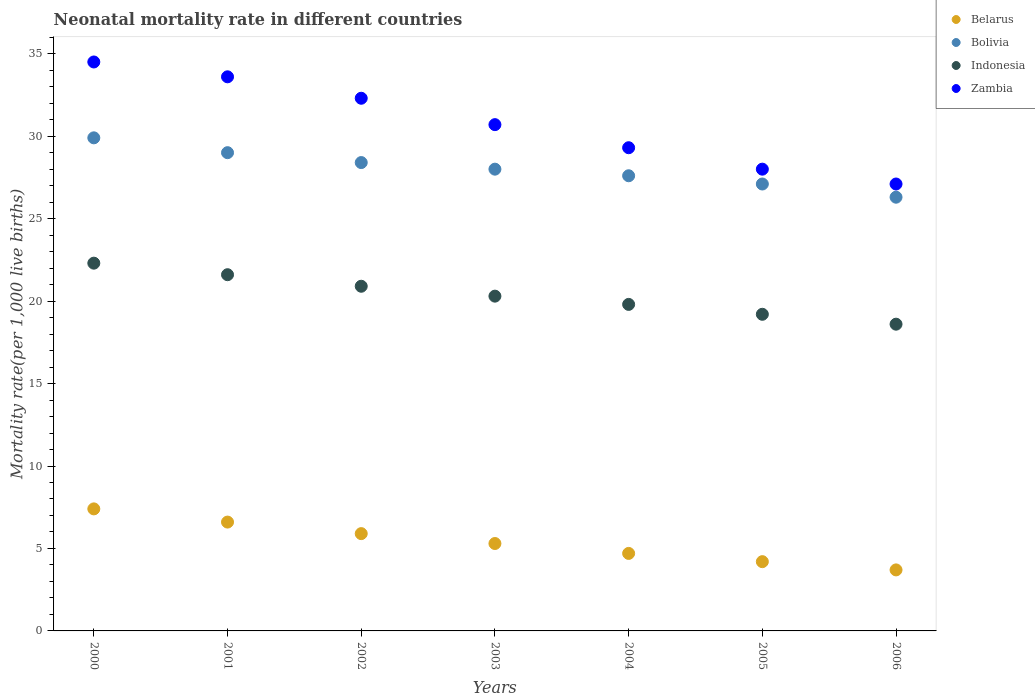How many different coloured dotlines are there?
Give a very brief answer. 4. What is the neonatal mortality rate in Belarus in 2000?
Offer a very short reply. 7.4. Across all years, what is the maximum neonatal mortality rate in Indonesia?
Keep it short and to the point. 22.3. Across all years, what is the minimum neonatal mortality rate in Zambia?
Offer a terse response. 27.1. In which year was the neonatal mortality rate in Indonesia minimum?
Provide a succinct answer. 2006. What is the total neonatal mortality rate in Bolivia in the graph?
Provide a succinct answer. 196.3. What is the difference between the neonatal mortality rate in Zambia in 2004 and that in 2005?
Offer a terse response. 1.3. What is the difference between the neonatal mortality rate in Zambia in 2002 and the neonatal mortality rate in Bolivia in 2001?
Offer a very short reply. 3.3. In how many years, is the neonatal mortality rate in Belarus greater than 9?
Ensure brevity in your answer.  0. What is the ratio of the neonatal mortality rate in Indonesia in 2003 to that in 2006?
Your response must be concise. 1.09. Is the neonatal mortality rate in Indonesia in 2004 less than that in 2005?
Your answer should be compact. No. What is the difference between the highest and the second highest neonatal mortality rate in Zambia?
Give a very brief answer. 0.9. What is the difference between the highest and the lowest neonatal mortality rate in Indonesia?
Keep it short and to the point. 3.7. Is it the case that in every year, the sum of the neonatal mortality rate in Bolivia and neonatal mortality rate in Belarus  is greater than the sum of neonatal mortality rate in Indonesia and neonatal mortality rate in Zambia?
Keep it short and to the point. Yes. Does the neonatal mortality rate in Bolivia monotonically increase over the years?
Your response must be concise. No. How many dotlines are there?
Ensure brevity in your answer.  4. Are the values on the major ticks of Y-axis written in scientific E-notation?
Offer a terse response. No. Does the graph contain any zero values?
Make the answer very short. No. Does the graph contain grids?
Provide a short and direct response. No. Where does the legend appear in the graph?
Provide a succinct answer. Top right. How are the legend labels stacked?
Provide a succinct answer. Vertical. What is the title of the graph?
Provide a succinct answer. Neonatal mortality rate in different countries. What is the label or title of the Y-axis?
Give a very brief answer. Mortality rate(per 1,0 live births). What is the Mortality rate(per 1,000 live births) of Bolivia in 2000?
Your answer should be very brief. 29.9. What is the Mortality rate(per 1,000 live births) in Indonesia in 2000?
Offer a terse response. 22.3. What is the Mortality rate(per 1,000 live births) of Zambia in 2000?
Your answer should be very brief. 34.5. What is the Mortality rate(per 1,000 live births) in Indonesia in 2001?
Keep it short and to the point. 21.6. What is the Mortality rate(per 1,000 live births) in Zambia in 2001?
Your response must be concise. 33.6. What is the Mortality rate(per 1,000 live births) of Belarus in 2002?
Give a very brief answer. 5.9. What is the Mortality rate(per 1,000 live births) in Bolivia in 2002?
Keep it short and to the point. 28.4. What is the Mortality rate(per 1,000 live births) in Indonesia in 2002?
Keep it short and to the point. 20.9. What is the Mortality rate(per 1,000 live births) in Zambia in 2002?
Offer a terse response. 32.3. What is the Mortality rate(per 1,000 live births) in Bolivia in 2003?
Your answer should be very brief. 28. What is the Mortality rate(per 1,000 live births) of Indonesia in 2003?
Give a very brief answer. 20.3. What is the Mortality rate(per 1,000 live births) of Zambia in 2003?
Give a very brief answer. 30.7. What is the Mortality rate(per 1,000 live births) in Belarus in 2004?
Give a very brief answer. 4.7. What is the Mortality rate(per 1,000 live births) of Bolivia in 2004?
Give a very brief answer. 27.6. What is the Mortality rate(per 1,000 live births) in Indonesia in 2004?
Offer a very short reply. 19.8. What is the Mortality rate(per 1,000 live births) of Zambia in 2004?
Ensure brevity in your answer.  29.3. What is the Mortality rate(per 1,000 live births) of Bolivia in 2005?
Keep it short and to the point. 27.1. What is the Mortality rate(per 1,000 live births) of Indonesia in 2005?
Your answer should be compact. 19.2. What is the Mortality rate(per 1,000 live births) in Zambia in 2005?
Provide a succinct answer. 28. What is the Mortality rate(per 1,000 live births) of Belarus in 2006?
Your answer should be very brief. 3.7. What is the Mortality rate(per 1,000 live births) in Bolivia in 2006?
Keep it short and to the point. 26.3. What is the Mortality rate(per 1,000 live births) of Zambia in 2006?
Offer a terse response. 27.1. Across all years, what is the maximum Mortality rate(per 1,000 live births) of Bolivia?
Your response must be concise. 29.9. Across all years, what is the maximum Mortality rate(per 1,000 live births) in Indonesia?
Make the answer very short. 22.3. Across all years, what is the maximum Mortality rate(per 1,000 live births) in Zambia?
Offer a very short reply. 34.5. Across all years, what is the minimum Mortality rate(per 1,000 live births) of Bolivia?
Provide a succinct answer. 26.3. Across all years, what is the minimum Mortality rate(per 1,000 live births) of Zambia?
Provide a succinct answer. 27.1. What is the total Mortality rate(per 1,000 live births) of Belarus in the graph?
Keep it short and to the point. 37.8. What is the total Mortality rate(per 1,000 live births) in Bolivia in the graph?
Your answer should be compact. 196.3. What is the total Mortality rate(per 1,000 live births) of Indonesia in the graph?
Provide a short and direct response. 142.7. What is the total Mortality rate(per 1,000 live births) of Zambia in the graph?
Offer a terse response. 215.5. What is the difference between the Mortality rate(per 1,000 live births) of Belarus in 2000 and that in 2001?
Make the answer very short. 0.8. What is the difference between the Mortality rate(per 1,000 live births) of Bolivia in 2000 and that in 2001?
Make the answer very short. 0.9. What is the difference between the Mortality rate(per 1,000 live births) in Belarus in 2000 and that in 2002?
Make the answer very short. 1.5. What is the difference between the Mortality rate(per 1,000 live births) in Bolivia in 2000 and that in 2002?
Give a very brief answer. 1.5. What is the difference between the Mortality rate(per 1,000 live births) of Indonesia in 2000 and that in 2002?
Your answer should be very brief. 1.4. What is the difference between the Mortality rate(per 1,000 live births) of Zambia in 2000 and that in 2002?
Ensure brevity in your answer.  2.2. What is the difference between the Mortality rate(per 1,000 live births) of Belarus in 2000 and that in 2003?
Make the answer very short. 2.1. What is the difference between the Mortality rate(per 1,000 live births) of Bolivia in 2000 and that in 2003?
Give a very brief answer. 1.9. What is the difference between the Mortality rate(per 1,000 live births) of Zambia in 2000 and that in 2003?
Give a very brief answer. 3.8. What is the difference between the Mortality rate(per 1,000 live births) in Indonesia in 2000 and that in 2004?
Your answer should be very brief. 2.5. What is the difference between the Mortality rate(per 1,000 live births) in Zambia in 2000 and that in 2004?
Give a very brief answer. 5.2. What is the difference between the Mortality rate(per 1,000 live births) of Belarus in 2000 and that in 2005?
Provide a succinct answer. 3.2. What is the difference between the Mortality rate(per 1,000 live births) in Bolivia in 2000 and that in 2005?
Ensure brevity in your answer.  2.8. What is the difference between the Mortality rate(per 1,000 live births) in Indonesia in 2000 and that in 2005?
Your answer should be very brief. 3.1. What is the difference between the Mortality rate(per 1,000 live births) of Zambia in 2000 and that in 2005?
Provide a short and direct response. 6.5. What is the difference between the Mortality rate(per 1,000 live births) in Bolivia in 2000 and that in 2006?
Provide a succinct answer. 3.6. What is the difference between the Mortality rate(per 1,000 live births) in Zambia in 2000 and that in 2006?
Ensure brevity in your answer.  7.4. What is the difference between the Mortality rate(per 1,000 live births) of Bolivia in 2001 and that in 2002?
Provide a succinct answer. 0.6. What is the difference between the Mortality rate(per 1,000 live births) in Zambia in 2001 and that in 2002?
Your response must be concise. 1.3. What is the difference between the Mortality rate(per 1,000 live births) in Indonesia in 2001 and that in 2003?
Keep it short and to the point. 1.3. What is the difference between the Mortality rate(per 1,000 live births) of Zambia in 2001 and that in 2003?
Keep it short and to the point. 2.9. What is the difference between the Mortality rate(per 1,000 live births) of Belarus in 2001 and that in 2004?
Your answer should be compact. 1.9. What is the difference between the Mortality rate(per 1,000 live births) in Bolivia in 2001 and that in 2004?
Ensure brevity in your answer.  1.4. What is the difference between the Mortality rate(per 1,000 live births) of Zambia in 2001 and that in 2004?
Keep it short and to the point. 4.3. What is the difference between the Mortality rate(per 1,000 live births) of Bolivia in 2001 and that in 2005?
Your answer should be very brief. 1.9. What is the difference between the Mortality rate(per 1,000 live births) in Belarus in 2001 and that in 2006?
Make the answer very short. 2.9. What is the difference between the Mortality rate(per 1,000 live births) in Indonesia in 2001 and that in 2006?
Ensure brevity in your answer.  3. What is the difference between the Mortality rate(per 1,000 live births) in Belarus in 2002 and that in 2003?
Your answer should be compact. 0.6. What is the difference between the Mortality rate(per 1,000 live births) in Indonesia in 2002 and that in 2003?
Give a very brief answer. 0.6. What is the difference between the Mortality rate(per 1,000 live births) of Zambia in 2002 and that in 2003?
Make the answer very short. 1.6. What is the difference between the Mortality rate(per 1,000 live births) of Indonesia in 2002 and that in 2004?
Offer a terse response. 1.1. What is the difference between the Mortality rate(per 1,000 live births) of Belarus in 2002 and that in 2005?
Keep it short and to the point. 1.7. What is the difference between the Mortality rate(per 1,000 live births) in Bolivia in 2002 and that in 2005?
Give a very brief answer. 1.3. What is the difference between the Mortality rate(per 1,000 live births) of Zambia in 2002 and that in 2005?
Keep it short and to the point. 4.3. What is the difference between the Mortality rate(per 1,000 live births) of Bolivia in 2002 and that in 2006?
Offer a very short reply. 2.1. What is the difference between the Mortality rate(per 1,000 live births) in Indonesia in 2002 and that in 2006?
Offer a very short reply. 2.3. What is the difference between the Mortality rate(per 1,000 live births) in Bolivia in 2003 and that in 2004?
Keep it short and to the point. 0.4. What is the difference between the Mortality rate(per 1,000 live births) of Zambia in 2003 and that in 2004?
Offer a very short reply. 1.4. What is the difference between the Mortality rate(per 1,000 live births) in Belarus in 2003 and that in 2005?
Keep it short and to the point. 1.1. What is the difference between the Mortality rate(per 1,000 live births) of Bolivia in 2003 and that in 2005?
Offer a very short reply. 0.9. What is the difference between the Mortality rate(per 1,000 live births) of Bolivia in 2003 and that in 2006?
Keep it short and to the point. 1.7. What is the difference between the Mortality rate(per 1,000 live births) in Indonesia in 2003 and that in 2006?
Give a very brief answer. 1.7. What is the difference between the Mortality rate(per 1,000 live births) of Indonesia in 2004 and that in 2005?
Your answer should be compact. 0.6. What is the difference between the Mortality rate(per 1,000 live births) of Zambia in 2004 and that in 2005?
Give a very brief answer. 1.3. What is the difference between the Mortality rate(per 1,000 live births) in Zambia in 2004 and that in 2006?
Ensure brevity in your answer.  2.2. What is the difference between the Mortality rate(per 1,000 live births) in Belarus in 2000 and the Mortality rate(per 1,000 live births) in Bolivia in 2001?
Make the answer very short. -21.6. What is the difference between the Mortality rate(per 1,000 live births) of Belarus in 2000 and the Mortality rate(per 1,000 live births) of Indonesia in 2001?
Your answer should be very brief. -14.2. What is the difference between the Mortality rate(per 1,000 live births) of Belarus in 2000 and the Mortality rate(per 1,000 live births) of Zambia in 2001?
Make the answer very short. -26.2. What is the difference between the Mortality rate(per 1,000 live births) in Bolivia in 2000 and the Mortality rate(per 1,000 live births) in Indonesia in 2001?
Ensure brevity in your answer.  8.3. What is the difference between the Mortality rate(per 1,000 live births) of Bolivia in 2000 and the Mortality rate(per 1,000 live births) of Zambia in 2001?
Make the answer very short. -3.7. What is the difference between the Mortality rate(per 1,000 live births) in Belarus in 2000 and the Mortality rate(per 1,000 live births) in Bolivia in 2002?
Your answer should be compact. -21. What is the difference between the Mortality rate(per 1,000 live births) of Belarus in 2000 and the Mortality rate(per 1,000 live births) of Zambia in 2002?
Ensure brevity in your answer.  -24.9. What is the difference between the Mortality rate(per 1,000 live births) of Bolivia in 2000 and the Mortality rate(per 1,000 live births) of Indonesia in 2002?
Make the answer very short. 9. What is the difference between the Mortality rate(per 1,000 live births) in Indonesia in 2000 and the Mortality rate(per 1,000 live births) in Zambia in 2002?
Give a very brief answer. -10. What is the difference between the Mortality rate(per 1,000 live births) in Belarus in 2000 and the Mortality rate(per 1,000 live births) in Bolivia in 2003?
Provide a short and direct response. -20.6. What is the difference between the Mortality rate(per 1,000 live births) of Belarus in 2000 and the Mortality rate(per 1,000 live births) of Zambia in 2003?
Offer a very short reply. -23.3. What is the difference between the Mortality rate(per 1,000 live births) of Bolivia in 2000 and the Mortality rate(per 1,000 live births) of Zambia in 2003?
Make the answer very short. -0.8. What is the difference between the Mortality rate(per 1,000 live births) in Indonesia in 2000 and the Mortality rate(per 1,000 live births) in Zambia in 2003?
Offer a terse response. -8.4. What is the difference between the Mortality rate(per 1,000 live births) of Belarus in 2000 and the Mortality rate(per 1,000 live births) of Bolivia in 2004?
Your answer should be very brief. -20.2. What is the difference between the Mortality rate(per 1,000 live births) in Belarus in 2000 and the Mortality rate(per 1,000 live births) in Zambia in 2004?
Ensure brevity in your answer.  -21.9. What is the difference between the Mortality rate(per 1,000 live births) in Bolivia in 2000 and the Mortality rate(per 1,000 live births) in Indonesia in 2004?
Give a very brief answer. 10.1. What is the difference between the Mortality rate(per 1,000 live births) of Bolivia in 2000 and the Mortality rate(per 1,000 live births) of Zambia in 2004?
Give a very brief answer. 0.6. What is the difference between the Mortality rate(per 1,000 live births) of Indonesia in 2000 and the Mortality rate(per 1,000 live births) of Zambia in 2004?
Your response must be concise. -7. What is the difference between the Mortality rate(per 1,000 live births) in Belarus in 2000 and the Mortality rate(per 1,000 live births) in Bolivia in 2005?
Provide a short and direct response. -19.7. What is the difference between the Mortality rate(per 1,000 live births) in Belarus in 2000 and the Mortality rate(per 1,000 live births) in Zambia in 2005?
Your answer should be very brief. -20.6. What is the difference between the Mortality rate(per 1,000 live births) of Indonesia in 2000 and the Mortality rate(per 1,000 live births) of Zambia in 2005?
Offer a very short reply. -5.7. What is the difference between the Mortality rate(per 1,000 live births) in Belarus in 2000 and the Mortality rate(per 1,000 live births) in Bolivia in 2006?
Give a very brief answer. -18.9. What is the difference between the Mortality rate(per 1,000 live births) of Belarus in 2000 and the Mortality rate(per 1,000 live births) of Indonesia in 2006?
Your response must be concise. -11.2. What is the difference between the Mortality rate(per 1,000 live births) in Belarus in 2000 and the Mortality rate(per 1,000 live births) in Zambia in 2006?
Offer a terse response. -19.7. What is the difference between the Mortality rate(per 1,000 live births) of Bolivia in 2000 and the Mortality rate(per 1,000 live births) of Indonesia in 2006?
Your answer should be compact. 11.3. What is the difference between the Mortality rate(per 1,000 live births) in Indonesia in 2000 and the Mortality rate(per 1,000 live births) in Zambia in 2006?
Provide a short and direct response. -4.8. What is the difference between the Mortality rate(per 1,000 live births) in Belarus in 2001 and the Mortality rate(per 1,000 live births) in Bolivia in 2002?
Your answer should be very brief. -21.8. What is the difference between the Mortality rate(per 1,000 live births) in Belarus in 2001 and the Mortality rate(per 1,000 live births) in Indonesia in 2002?
Your answer should be compact. -14.3. What is the difference between the Mortality rate(per 1,000 live births) of Belarus in 2001 and the Mortality rate(per 1,000 live births) of Zambia in 2002?
Your response must be concise. -25.7. What is the difference between the Mortality rate(per 1,000 live births) in Bolivia in 2001 and the Mortality rate(per 1,000 live births) in Indonesia in 2002?
Provide a succinct answer. 8.1. What is the difference between the Mortality rate(per 1,000 live births) of Belarus in 2001 and the Mortality rate(per 1,000 live births) of Bolivia in 2003?
Offer a terse response. -21.4. What is the difference between the Mortality rate(per 1,000 live births) in Belarus in 2001 and the Mortality rate(per 1,000 live births) in Indonesia in 2003?
Give a very brief answer. -13.7. What is the difference between the Mortality rate(per 1,000 live births) in Belarus in 2001 and the Mortality rate(per 1,000 live births) in Zambia in 2003?
Ensure brevity in your answer.  -24.1. What is the difference between the Mortality rate(per 1,000 live births) in Belarus in 2001 and the Mortality rate(per 1,000 live births) in Zambia in 2004?
Your answer should be very brief. -22.7. What is the difference between the Mortality rate(per 1,000 live births) in Bolivia in 2001 and the Mortality rate(per 1,000 live births) in Indonesia in 2004?
Give a very brief answer. 9.2. What is the difference between the Mortality rate(per 1,000 live births) in Indonesia in 2001 and the Mortality rate(per 1,000 live births) in Zambia in 2004?
Offer a terse response. -7.7. What is the difference between the Mortality rate(per 1,000 live births) of Belarus in 2001 and the Mortality rate(per 1,000 live births) of Bolivia in 2005?
Your answer should be very brief. -20.5. What is the difference between the Mortality rate(per 1,000 live births) in Belarus in 2001 and the Mortality rate(per 1,000 live births) in Zambia in 2005?
Provide a short and direct response. -21.4. What is the difference between the Mortality rate(per 1,000 live births) of Indonesia in 2001 and the Mortality rate(per 1,000 live births) of Zambia in 2005?
Offer a very short reply. -6.4. What is the difference between the Mortality rate(per 1,000 live births) of Belarus in 2001 and the Mortality rate(per 1,000 live births) of Bolivia in 2006?
Make the answer very short. -19.7. What is the difference between the Mortality rate(per 1,000 live births) of Belarus in 2001 and the Mortality rate(per 1,000 live births) of Zambia in 2006?
Ensure brevity in your answer.  -20.5. What is the difference between the Mortality rate(per 1,000 live births) in Bolivia in 2001 and the Mortality rate(per 1,000 live births) in Indonesia in 2006?
Keep it short and to the point. 10.4. What is the difference between the Mortality rate(per 1,000 live births) of Bolivia in 2001 and the Mortality rate(per 1,000 live births) of Zambia in 2006?
Give a very brief answer. 1.9. What is the difference between the Mortality rate(per 1,000 live births) of Belarus in 2002 and the Mortality rate(per 1,000 live births) of Bolivia in 2003?
Your answer should be compact. -22.1. What is the difference between the Mortality rate(per 1,000 live births) of Belarus in 2002 and the Mortality rate(per 1,000 live births) of Indonesia in 2003?
Offer a terse response. -14.4. What is the difference between the Mortality rate(per 1,000 live births) in Belarus in 2002 and the Mortality rate(per 1,000 live births) in Zambia in 2003?
Make the answer very short. -24.8. What is the difference between the Mortality rate(per 1,000 live births) of Bolivia in 2002 and the Mortality rate(per 1,000 live births) of Indonesia in 2003?
Keep it short and to the point. 8.1. What is the difference between the Mortality rate(per 1,000 live births) of Bolivia in 2002 and the Mortality rate(per 1,000 live births) of Zambia in 2003?
Your response must be concise. -2.3. What is the difference between the Mortality rate(per 1,000 live births) of Belarus in 2002 and the Mortality rate(per 1,000 live births) of Bolivia in 2004?
Offer a very short reply. -21.7. What is the difference between the Mortality rate(per 1,000 live births) of Belarus in 2002 and the Mortality rate(per 1,000 live births) of Zambia in 2004?
Offer a terse response. -23.4. What is the difference between the Mortality rate(per 1,000 live births) of Bolivia in 2002 and the Mortality rate(per 1,000 live births) of Zambia in 2004?
Provide a short and direct response. -0.9. What is the difference between the Mortality rate(per 1,000 live births) in Belarus in 2002 and the Mortality rate(per 1,000 live births) in Bolivia in 2005?
Provide a succinct answer. -21.2. What is the difference between the Mortality rate(per 1,000 live births) of Belarus in 2002 and the Mortality rate(per 1,000 live births) of Zambia in 2005?
Ensure brevity in your answer.  -22.1. What is the difference between the Mortality rate(per 1,000 live births) of Bolivia in 2002 and the Mortality rate(per 1,000 live births) of Indonesia in 2005?
Make the answer very short. 9.2. What is the difference between the Mortality rate(per 1,000 live births) of Bolivia in 2002 and the Mortality rate(per 1,000 live births) of Zambia in 2005?
Provide a succinct answer. 0.4. What is the difference between the Mortality rate(per 1,000 live births) of Belarus in 2002 and the Mortality rate(per 1,000 live births) of Bolivia in 2006?
Your response must be concise. -20.4. What is the difference between the Mortality rate(per 1,000 live births) in Belarus in 2002 and the Mortality rate(per 1,000 live births) in Indonesia in 2006?
Offer a very short reply. -12.7. What is the difference between the Mortality rate(per 1,000 live births) of Belarus in 2002 and the Mortality rate(per 1,000 live births) of Zambia in 2006?
Provide a succinct answer. -21.2. What is the difference between the Mortality rate(per 1,000 live births) of Bolivia in 2002 and the Mortality rate(per 1,000 live births) of Indonesia in 2006?
Your answer should be very brief. 9.8. What is the difference between the Mortality rate(per 1,000 live births) of Belarus in 2003 and the Mortality rate(per 1,000 live births) of Bolivia in 2004?
Your response must be concise. -22.3. What is the difference between the Mortality rate(per 1,000 live births) in Bolivia in 2003 and the Mortality rate(per 1,000 live births) in Zambia in 2004?
Provide a succinct answer. -1.3. What is the difference between the Mortality rate(per 1,000 live births) in Indonesia in 2003 and the Mortality rate(per 1,000 live births) in Zambia in 2004?
Make the answer very short. -9. What is the difference between the Mortality rate(per 1,000 live births) in Belarus in 2003 and the Mortality rate(per 1,000 live births) in Bolivia in 2005?
Offer a very short reply. -21.8. What is the difference between the Mortality rate(per 1,000 live births) in Belarus in 2003 and the Mortality rate(per 1,000 live births) in Zambia in 2005?
Provide a short and direct response. -22.7. What is the difference between the Mortality rate(per 1,000 live births) in Bolivia in 2003 and the Mortality rate(per 1,000 live births) in Indonesia in 2005?
Offer a very short reply. 8.8. What is the difference between the Mortality rate(per 1,000 live births) in Belarus in 2003 and the Mortality rate(per 1,000 live births) in Indonesia in 2006?
Your answer should be compact. -13.3. What is the difference between the Mortality rate(per 1,000 live births) of Belarus in 2003 and the Mortality rate(per 1,000 live births) of Zambia in 2006?
Provide a succinct answer. -21.8. What is the difference between the Mortality rate(per 1,000 live births) of Bolivia in 2003 and the Mortality rate(per 1,000 live births) of Indonesia in 2006?
Offer a very short reply. 9.4. What is the difference between the Mortality rate(per 1,000 live births) of Indonesia in 2003 and the Mortality rate(per 1,000 live births) of Zambia in 2006?
Your answer should be very brief. -6.8. What is the difference between the Mortality rate(per 1,000 live births) of Belarus in 2004 and the Mortality rate(per 1,000 live births) of Bolivia in 2005?
Provide a short and direct response. -22.4. What is the difference between the Mortality rate(per 1,000 live births) in Belarus in 2004 and the Mortality rate(per 1,000 live births) in Indonesia in 2005?
Offer a very short reply. -14.5. What is the difference between the Mortality rate(per 1,000 live births) in Belarus in 2004 and the Mortality rate(per 1,000 live births) in Zambia in 2005?
Your response must be concise. -23.3. What is the difference between the Mortality rate(per 1,000 live births) in Bolivia in 2004 and the Mortality rate(per 1,000 live births) in Indonesia in 2005?
Your response must be concise. 8.4. What is the difference between the Mortality rate(per 1,000 live births) of Belarus in 2004 and the Mortality rate(per 1,000 live births) of Bolivia in 2006?
Ensure brevity in your answer.  -21.6. What is the difference between the Mortality rate(per 1,000 live births) of Belarus in 2004 and the Mortality rate(per 1,000 live births) of Indonesia in 2006?
Keep it short and to the point. -13.9. What is the difference between the Mortality rate(per 1,000 live births) of Belarus in 2004 and the Mortality rate(per 1,000 live births) of Zambia in 2006?
Ensure brevity in your answer.  -22.4. What is the difference between the Mortality rate(per 1,000 live births) in Bolivia in 2004 and the Mortality rate(per 1,000 live births) in Zambia in 2006?
Keep it short and to the point. 0.5. What is the difference between the Mortality rate(per 1,000 live births) of Belarus in 2005 and the Mortality rate(per 1,000 live births) of Bolivia in 2006?
Your response must be concise. -22.1. What is the difference between the Mortality rate(per 1,000 live births) in Belarus in 2005 and the Mortality rate(per 1,000 live births) in Indonesia in 2006?
Make the answer very short. -14.4. What is the difference between the Mortality rate(per 1,000 live births) of Belarus in 2005 and the Mortality rate(per 1,000 live births) of Zambia in 2006?
Your answer should be very brief. -22.9. What is the average Mortality rate(per 1,000 live births) of Bolivia per year?
Offer a very short reply. 28.04. What is the average Mortality rate(per 1,000 live births) of Indonesia per year?
Provide a succinct answer. 20.39. What is the average Mortality rate(per 1,000 live births) in Zambia per year?
Give a very brief answer. 30.79. In the year 2000, what is the difference between the Mortality rate(per 1,000 live births) of Belarus and Mortality rate(per 1,000 live births) of Bolivia?
Ensure brevity in your answer.  -22.5. In the year 2000, what is the difference between the Mortality rate(per 1,000 live births) of Belarus and Mortality rate(per 1,000 live births) of Indonesia?
Offer a very short reply. -14.9. In the year 2000, what is the difference between the Mortality rate(per 1,000 live births) in Belarus and Mortality rate(per 1,000 live births) in Zambia?
Your answer should be very brief. -27.1. In the year 2001, what is the difference between the Mortality rate(per 1,000 live births) in Belarus and Mortality rate(per 1,000 live births) in Bolivia?
Give a very brief answer. -22.4. In the year 2001, what is the difference between the Mortality rate(per 1,000 live births) in Belarus and Mortality rate(per 1,000 live births) in Indonesia?
Your answer should be compact. -15. In the year 2001, what is the difference between the Mortality rate(per 1,000 live births) of Bolivia and Mortality rate(per 1,000 live births) of Indonesia?
Ensure brevity in your answer.  7.4. In the year 2002, what is the difference between the Mortality rate(per 1,000 live births) in Belarus and Mortality rate(per 1,000 live births) in Bolivia?
Provide a short and direct response. -22.5. In the year 2002, what is the difference between the Mortality rate(per 1,000 live births) in Belarus and Mortality rate(per 1,000 live births) in Indonesia?
Give a very brief answer. -15. In the year 2002, what is the difference between the Mortality rate(per 1,000 live births) in Belarus and Mortality rate(per 1,000 live births) in Zambia?
Give a very brief answer. -26.4. In the year 2002, what is the difference between the Mortality rate(per 1,000 live births) in Bolivia and Mortality rate(per 1,000 live births) in Zambia?
Make the answer very short. -3.9. In the year 2003, what is the difference between the Mortality rate(per 1,000 live births) in Belarus and Mortality rate(per 1,000 live births) in Bolivia?
Your answer should be compact. -22.7. In the year 2003, what is the difference between the Mortality rate(per 1,000 live births) in Belarus and Mortality rate(per 1,000 live births) in Zambia?
Ensure brevity in your answer.  -25.4. In the year 2003, what is the difference between the Mortality rate(per 1,000 live births) of Bolivia and Mortality rate(per 1,000 live births) of Indonesia?
Give a very brief answer. 7.7. In the year 2003, what is the difference between the Mortality rate(per 1,000 live births) of Bolivia and Mortality rate(per 1,000 live births) of Zambia?
Provide a succinct answer. -2.7. In the year 2004, what is the difference between the Mortality rate(per 1,000 live births) of Belarus and Mortality rate(per 1,000 live births) of Bolivia?
Ensure brevity in your answer.  -22.9. In the year 2004, what is the difference between the Mortality rate(per 1,000 live births) of Belarus and Mortality rate(per 1,000 live births) of Indonesia?
Keep it short and to the point. -15.1. In the year 2004, what is the difference between the Mortality rate(per 1,000 live births) in Belarus and Mortality rate(per 1,000 live births) in Zambia?
Offer a terse response. -24.6. In the year 2004, what is the difference between the Mortality rate(per 1,000 live births) in Bolivia and Mortality rate(per 1,000 live births) in Indonesia?
Offer a terse response. 7.8. In the year 2004, what is the difference between the Mortality rate(per 1,000 live births) in Bolivia and Mortality rate(per 1,000 live births) in Zambia?
Give a very brief answer. -1.7. In the year 2004, what is the difference between the Mortality rate(per 1,000 live births) of Indonesia and Mortality rate(per 1,000 live births) of Zambia?
Give a very brief answer. -9.5. In the year 2005, what is the difference between the Mortality rate(per 1,000 live births) of Belarus and Mortality rate(per 1,000 live births) of Bolivia?
Provide a short and direct response. -22.9. In the year 2005, what is the difference between the Mortality rate(per 1,000 live births) in Belarus and Mortality rate(per 1,000 live births) in Indonesia?
Provide a short and direct response. -15. In the year 2005, what is the difference between the Mortality rate(per 1,000 live births) in Belarus and Mortality rate(per 1,000 live births) in Zambia?
Offer a very short reply. -23.8. In the year 2006, what is the difference between the Mortality rate(per 1,000 live births) in Belarus and Mortality rate(per 1,000 live births) in Bolivia?
Your answer should be compact. -22.6. In the year 2006, what is the difference between the Mortality rate(per 1,000 live births) in Belarus and Mortality rate(per 1,000 live births) in Indonesia?
Your answer should be compact. -14.9. In the year 2006, what is the difference between the Mortality rate(per 1,000 live births) of Belarus and Mortality rate(per 1,000 live births) of Zambia?
Provide a succinct answer. -23.4. In the year 2006, what is the difference between the Mortality rate(per 1,000 live births) of Bolivia and Mortality rate(per 1,000 live births) of Zambia?
Provide a succinct answer. -0.8. What is the ratio of the Mortality rate(per 1,000 live births) of Belarus in 2000 to that in 2001?
Provide a short and direct response. 1.12. What is the ratio of the Mortality rate(per 1,000 live births) of Bolivia in 2000 to that in 2001?
Your answer should be very brief. 1.03. What is the ratio of the Mortality rate(per 1,000 live births) of Indonesia in 2000 to that in 2001?
Provide a succinct answer. 1.03. What is the ratio of the Mortality rate(per 1,000 live births) in Zambia in 2000 to that in 2001?
Offer a terse response. 1.03. What is the ratio of the Mortality rate(per 1,000 live births) of Belarus in 2000 to that in 2002?
Offer a terse response. 1.25. What is the ratio of the Mortality rate(per 1,000 live births) in Bolivia in 2000 to that in 2002?
Ensure brevity in your answer.  1.05. What is the ratio of the Mortality rate(per 1,000 live births) of Indonesia in 2000 to that in 2002?
Your answer should be very brief. 1.07. What is the ratio of the Mortality rate(per 1,000 live births) in Zambia in 2000 to that in 2002?
Keep it short and to the point. 1.07. What is the ratio of the Mortality rate(per 1,000 live births) in Belarus in 2000 to that in 2003?
Give a very brief answer. 1.4. What is the ratio of the Mortality rate(per 1,000 live births) in Bolivia in 2000 to that in 2003?
Keep it short and to the point. 1.07. What is the ratio of the Mortality rate(per 1,000 live births) of Indonesia in 2000 to that in 2003?
Make the answer very short. 1.1. What is the ratio of the Mortality rate(per 1,000 live births) of Zambia in 2000 to that in 2003?
Provide a short and direct response. 1.12. What is the ratio of the Mortality rate(per 1,000 live births) of Belarus in 2000 to that in 2004?
Give a very brief answer. 1.57. What is the ratio of the Mortality rate(per 1,000 live births) of Indonesia in 2000 to that in 2004?
Your answer should be compact. 1.13. What is the ratio of the Mortality rate(per 1,000 live births) in Zambia in 2000 to that in 2004?
Your answer should be very brief. 1.18. What is the ratio of the Mortality rate(per 1,000 live births) in Belarus in 2000 to that in 2005?
Ensure brevity in your answer.  1.76. What is the ratio of the Mortality rate(per 1,000 live births) in Bolivia in 2000 to that in 2005?
Your answer should be compact. 1.1. What is the ratio of the Mortality rate(per 1,000 live births) of Indonesia in 2000 to that in 2005?
Ensure brevity in your answer.  1.16. What is the ratio of the Mortality rate(per 1,000 live births) in Zambia in 2000 to that in 2005?
Offer a very short reply. 1.23. What is the ratio of the Mortality rate(per 1,000 live births) of Belarus in 2000 to that in 2006?
Your answer should be very brief. 2. What is the ratio of the Mortality rate(per 1,000 live births) of Bolivia in 2000 to that in 2006?
Give a very brief answer. 1.14. What is the ratio of the Mortality rate(per 1,000 live births) in Indonesia in 2000 to that in 2006?
Your answer should be compact. 1.2. What is the ratio of the Mortality rate(per 1,000 live births) in Zambia in 2000 to that in 2006?
Your answer should be compact. 1.27. What is the ratio of the Mortality rate(per 1,000 live births) of Belarus in 2001 to that in 2002?
Ensure brevity in your answer.  1.12. What is the ratio of the Mortality rate(per 1,000 live births) in Bolivia in 2001 to that in 2002?
Provide a short and direct response. 1.02. What is the ratio of the Mortality rate(per 1,000 live births) in Indonesia in 2001 to that in 2002?
Keep it short and to the point. 1.03. What is the ratio of the Mortality rate(per 1,000 live births) in Zambia in 2001 to that in 2002?
Ensure brevity in your answer.  1.04. What is the ratio of the Mortality rate(per 1,000 live births) in Belarus in 2001 to that in 2003?
Your answer should be very brief. 1.25. What is the ratio of the Mortality rate(per 1,000 live births) in Bolivia in 2001 to that in 2003?
Your answer should be very brief. 1.04. What is the ratio of the Mortality rate(per 1,000 live births) of Indonesia in 2001 to that in 2003?
Your answer should be compact. 1.06. What is the ratio of the Mortality rate(per 1,000 live births) in Zambia in 2001 to that in 2003?
Provide a succinct answer. 1.09. What is the ratio of the Mortality rate(per 1,000 live births) in Belarus in 2001 to that in 2004?
Your answer should be very brief. 1.4. What is the ratio of the Mortality rate(per 1,000 live births) of Bolivia in 2001 to that in 2004?
Your answer should be very brief. 1.05. What is the ratio of the Mortality rate(per 1,000 live births) in Indonesia in 2001 to that in 2004?
Offer a very short reply. 1.09. What is the ratio of the Mortality rate(per 1,000 live births) of Zambia in 2001 to that in 2004?
Keep it short and to the point. 1.15. What is the ratio of the Mortality rate(per 1,000 live births) of Belarus in 2001 to that in 2005?
Give a very brief answer. 1.57. What is the ratio of the Mortality rate(per 1,000 live births) of Bolivia in 2001 to that in 2005?
Your answer should be very brief. 1.07. What is the ratio of the Mortality rate(per 1,000 live births) of Belarus in 2001 to that in 2006?
Offer a very short reply. 1.78. What is the ratio of the Mortality rate(per 1,000 live births) of Bolivia in 2001 to that in 2006?
Keep it short and to the point. 1.1. What is the ratio of the Mortality rate(per 1,000 live births) of Indonesia in 2001 to that in 2006?
Make the answer very short. 1.16. What is the ratio of the Mortality rate(per 1,000 live births) of Zambia in 2001 to that in 2006?
Your response must be concise. 1.24. What is the ratio of the Mortality rate(per 1,000 live births) in Belarus in 2002 to that in 2003?
Keep it short and to the point. 1.11. What is the ratio of the Mortality rate(per 1,000 live births) in Bolivia in 2002 to that in 2003?
Offer a very short reply. 1.01. What is the ratio of the Mortality rate(per 1,000 live births) of Indonesia in 2002 to that in 2003?
Give a very brief answer. 1.03. What is the ratio of the Mortality rate(per 1,000 live births) of Zambia in 2002 to that in 2003?
Ensure brevity in your answer.  1.05. What is the ratio of the Mortality rate(per 1,000 live births) of Belarus in 2002 to that in 2004?
Your response must be concise. 1.26. What is the ratio of the Mortality rate(per 1,000 live births) in Bolivia in 2002 to that in 2004?
Give a very brief answer. 1.03. What is the ratio of the Mortality rate(per 1,000 live births) in Indonesia in 2002 to that in 2004?
Make the answer very short. 1.06. What is the ratio of the Mortality rate(per 1,000 live births) in Zambia in 2002 to that in 2004?
Offer a very short reply. 1.1. What is the ratio of the Mortality rate(per 1,000 live births) of Belarus in 2002 to that in 2005?
Ensure brevity in your answer.  1.4. What is the ratio of the Mortality rate(per 1,000 live births) of Bolivia in 2002 to that in 2005?
Offer a very short reply. 1.05. What is the ratio of the Mortality rate(per 1,000 live births) of Indonesia in 2002 to that in 2005?
Keep it short and to the point. 1.09. What is the ratio of the Mortality rate(per 1,000 live births) of Zambia in 2002 to that in 2005?
Your response must be concise. 1.15. What is the ratio of the Mortality rate(per 1,000 live births) in Belarus in 2002 to that in 2006?
Your answer should be compact. 1.59. What is the ratio of the Mortality rate(per 1,000 live births) in Bolivia in 2002 to that in 2006?
Ensure brevity in your answer.  1.08. What is the ratio of the Mortality rate(per 1,000 live births) in Indonesia in 2002 to that in 2006?
Keep it short and to the point. 1.12. What is the ratio of the Mortality rate(per 1,000 live births) of Zambia in 2002 to that in 2006?
Make the answer very short. 1.19. What is the ratio of the Mortality rate(per 1,000 live births) of Belarus in 2003 to that in 2004?
Provide a short and direct response. 1.13. What is the ratio of the Mortality rate(per 1,000 live births) in Bolivia in 2003 to that in 2004?
Ensure brevity in your answer.  1.01. What is the ratio of the Mortality rate(per 1,000 live births) in Indonesia in 2003 to that in 2004?
Offer a terse response. 1.03. What is the ratio of the Mortality rate(per 1,000 live births) in Zambia in 2003 to that in 2004?
Provide a succinct answer. 1.05. What is the ratio of the Mortality rate(per 1,000 live births) in Belarus in 2003 to that in 2005?
Offer a terse response. 1.26. What is the ratio of the Mortality rate(per 1,000 live births) of Bolivia in 2003 to that in 2005?
Keep it short and to the point. 1.03. What is the ratio of the Mortality rate(per 1,000 live births) in Indonesia in 2003 to that in 2005?
Your answer should be compact. 1.06. What is the ratio of the Mortality rate(per 1,000 live births) in Zambia in 2003 to that in 2005?
Make the answer very short. 1.1. What is the ratio of the Mortality rate(per 1,000 live births) of Belarus in 2003 to that in 2006?
Make the answer very short. 1.43. What is the ratio of the Mortality rate(per 1,000 live births) of Bolivia in 2003 to that in 2006?
Your answer should be very brief. 1.06. What is the ratio of the Mortality rate(per 1,000 live births) of Indonesia in 2003 to that in 2006?
Your answer should be compact. 1.09. What is the ratio of the Mortality rate(per 1,000 live births) in Zambia in 2003 to that in 2006?
Your answer should be compact. 1.13. What is the ratio of the Mortality rate(per 1,000 live births) of Belarus in 2004 to that in 2005?
Your response must be concise. 1.12. What is the ratio of the Mortality rate(per 1,000 live births) in Bolivia in 2004 to that in 2005?
Make the answer very short. 1.02. What is the ratio of the Mortality rate(per 1,000 live births) of Indonesia in 2004 to that in 2005?
Your answer should be compact. 1.03. What is the ratio of the Mortality rate(per 1,000 live births) in Zambia in 2004 to that in 2005?
Your answer should be compact. 1.05. What is the ratio of the Mortality rate(per 1,000 live births) of Belarus in 2004 to that in 2006?
Provide a succinct answer. 1.27. What is the ratio of the Mortality rate(per 1,000 live births) of Bolivia in 2004 to that in 2006?
Your response must be concise. 1.05. What is the ratio of the Mortality rate(per 1,000 live births) of Indonesia in 2004 to that in 2006?
Provide a succinct answer. 1.06. What is the ratio of the Mortality rate(per 1,000 live births) in Zambia in 2004 to that in 2006?
Offer a terse response. 1.08. What is the ratio of the Mortality rate(per 1,000 live births) of Belarus in 2005 to that in 2006?
Offer a terse response. 1.14. What is the ratio of the Mortality rate(per 1,000 live births) of Bolivia in 2005 to that in 2006?
Your answer should be very brief. 1.03. What is the ratio of the Mortality rate(per 1,000 live births) in Indonesia in 2005 to that in 2006?
Offer a very short reply. 1.03. What is the ratio of the Mortality rate(per 1,000 live births) in Zambia in 2005 to that in 2006?
Your response must be concise. 1.03. What is the difference between the highest and the second highest Mortality rate(per 1,000 live births) of Belarus?
Give a very brief answer. 0.8. What is the difference between the highest and the lowest Mortality rate(per 1,000 live births) in Bolivia?
Make the answer very short. 3.6. What is the difference between the highest and the lowest Mortality rate(per 1,000 live births) in Indonesia?
Your answer should be very brief. 3.7. 